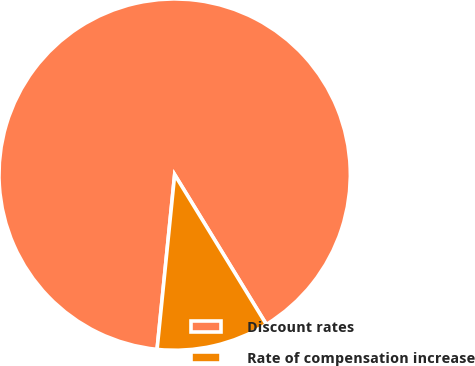Convert chart. <chart><loc_0><loc_0><loc_500><loc_500><pie_chart><fcel>Discount rates<fcel>Rate of compensation increase<nl><fcel>89.66%<fcel>10.34%<nl></chart> 